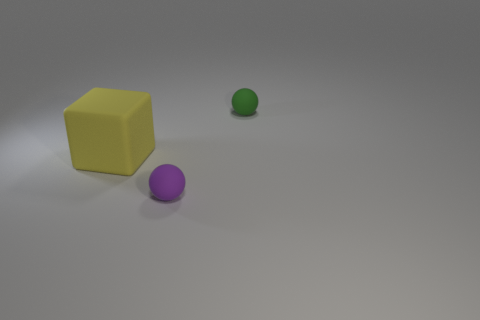What number of things are either large yellow objects or things behind the tiny purple rubber thing?
Your response must be concise. 2. The thing that is behind the purple matte ball and on the right side of the yellow cube is made of what material?
Provide a succinct answer. Rubber. Is there any other thing that has the same shape as the yellow object?
Give a very brief answer. No. There is a small thing that is the same material as the tiny purple ball; what is its color?
Your answer should be very brief. Green. What number of objects are either green cubes or yellow objects?
Provide a succinct answer. 1. Is the size of the green thing the same as the matte object in front of the yellow block?
Make the answer very short. Yes. There is a tiny matte thing in front of the cube that is behind the small rubber object left of the small green sphere; what is its color?
Offer a terse response. Purple. What color is the large object?
Keep it short and to the point. Yellow. Is the number of purple rubber things on the left side of the green ball greater than the number of big objects right of the purple matte ball?
Your response must be concise. Yes. Do the purple rubber thing and the rubber object that is on the left side of the purple ball have the same shape?
Keep it short and to the point. No. 